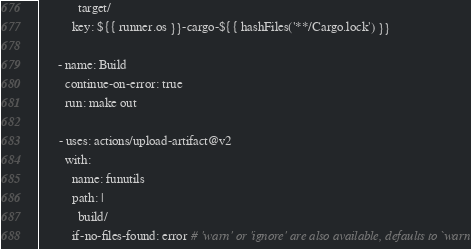<code> <loc_0><loc_0><loc_500><loc_500><_YAML_>            target/
          key: ${{ runner.os }}-cargo-${{ hashFiles('**/Cargo.lock') }}

      - name: Build
        continue-on-error: true
        run: make out

      - uses: actions/upload-artifact@v2
        with:
          name: funutils
          path: |
            build/
          if-no-files-found: error # 'warn' or 'ignore' are also available, defaults to `warn`
</code> 